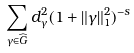<formula> <loc_0><loc_0><loc_500><loc_500>\sum _ { \gamma \in \widehat { G } } d _ { \gamma } ^ { 2 } ( 1 + \| \gamma \| ^ { 2 } _ { 1 } ) ^ { - s }</formula> 